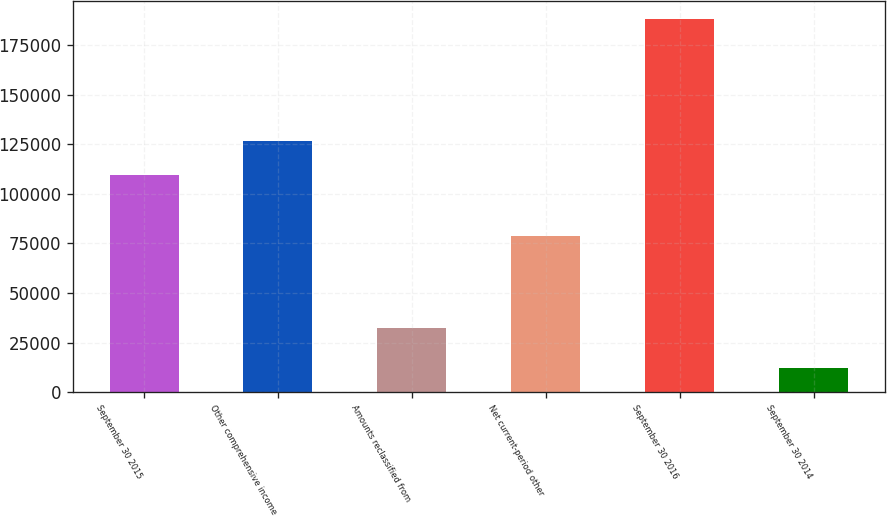<chart> <loc_0><loc_0><loc_500><loc_500><bar_chart><fcel>September 30 2015<fcel>Other comprehensive income<fcel>Amounts reclassified from<fcel>Net current-period other<fcel>September 30 2016<fcel>September 30 2014<nl><fcel>109330<fcel>126893<fcel>32262<fcel>78692<fcel>188022<fcel>12393<nl></chart> 